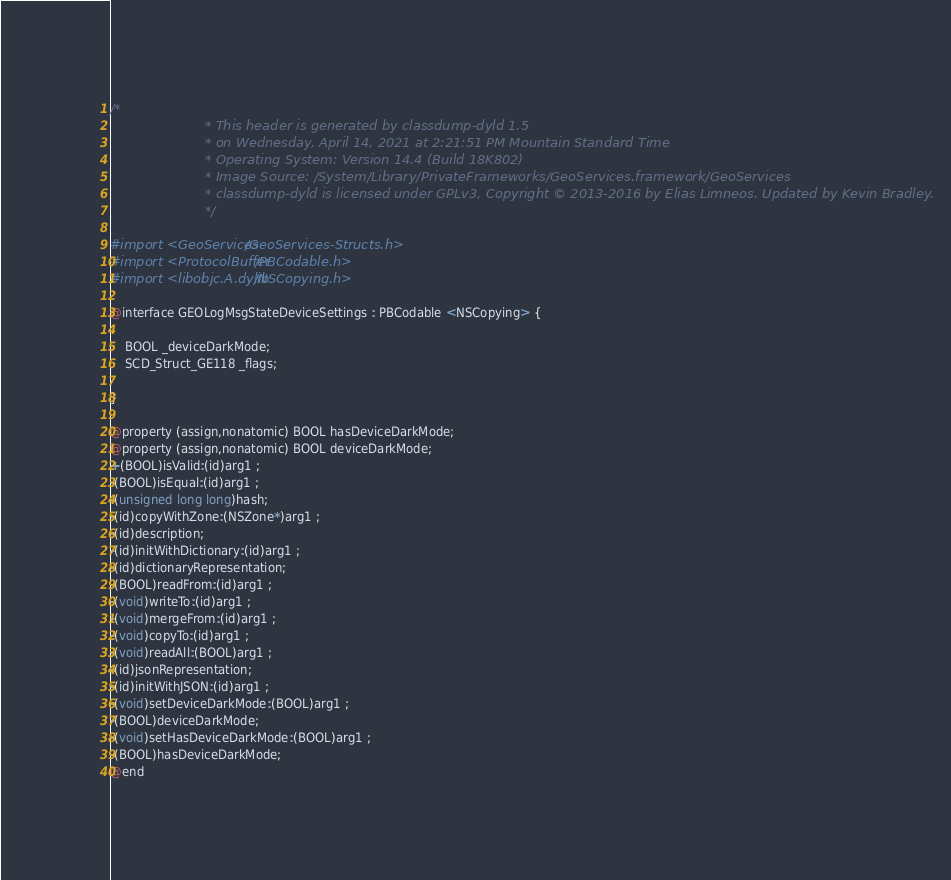<code> <loc_0><loc_0><loc_500><loc_500><_C_>/*
                       * This header is generated by classdump-dyld 1.5
                       * on Wednesday, April 14, 2021 at 2:21:51 PM Mountain Standard Time
                       * Operating System: Version 14.4 (Build 18K802)
                       * Image Source: /System/Library/PrivateFrameworks/GeoServices.framework/GeoServices
                       * classdump-dyld is licensed under GPLv3, Copyright © 2013-2016 by Elias Limneos. Updated by Kevin Bradley.
                       */

#import <GeoServices/GeoServices-Structs.h>
#import <ProtocolBuffer/PBCodable.h>
#import <libobjc.A.dylib/NSCopying.h>

@interface GEOLogMsgStateDeviceSettings : PBCodable <NSCopying> {

	BOOL _deviceDarkMode;
	SCD_Struct_GE118 _flags;

}

@property (assign,nonatomic) BOOL hasDeviceDarkMode; 
@property (assign,nonatomic) BOOL deviceDarkMode; 
+(BOOL)isValid:(id)arg1 ;
-(BOOL)isEqual:(id)arg1 ;
-(unsigned long long)hash;
-(id)copyWithZone:(NSZone*)arg1 ;
-(id)description;
-(id)initWithDictionary:(id)arg1 ;
-(id)dictionaryRepresentation;
-(BOOL)readFrom:(id)arg1 ;
-(void)writeTo:(id)arg1 ;
-(void)mergeFrom:(id)arg1 ;
-(void)copyTo:(id)arg1 ;
-(void)readAll:(BOOL)arg1 ;
-(id)jsonRepresentation;
-(id)initWithJSON:(id)arg1 ;
-(void)setDeviceDarkMode:(BOOL)arg1 ;
-(BOOL)deviceDarkMode;
-(void)setHasDeviceDarkMode:(BOOL)arg1 ;
-(BOOL)hasDeviceDarkMode;
@end

</code> 